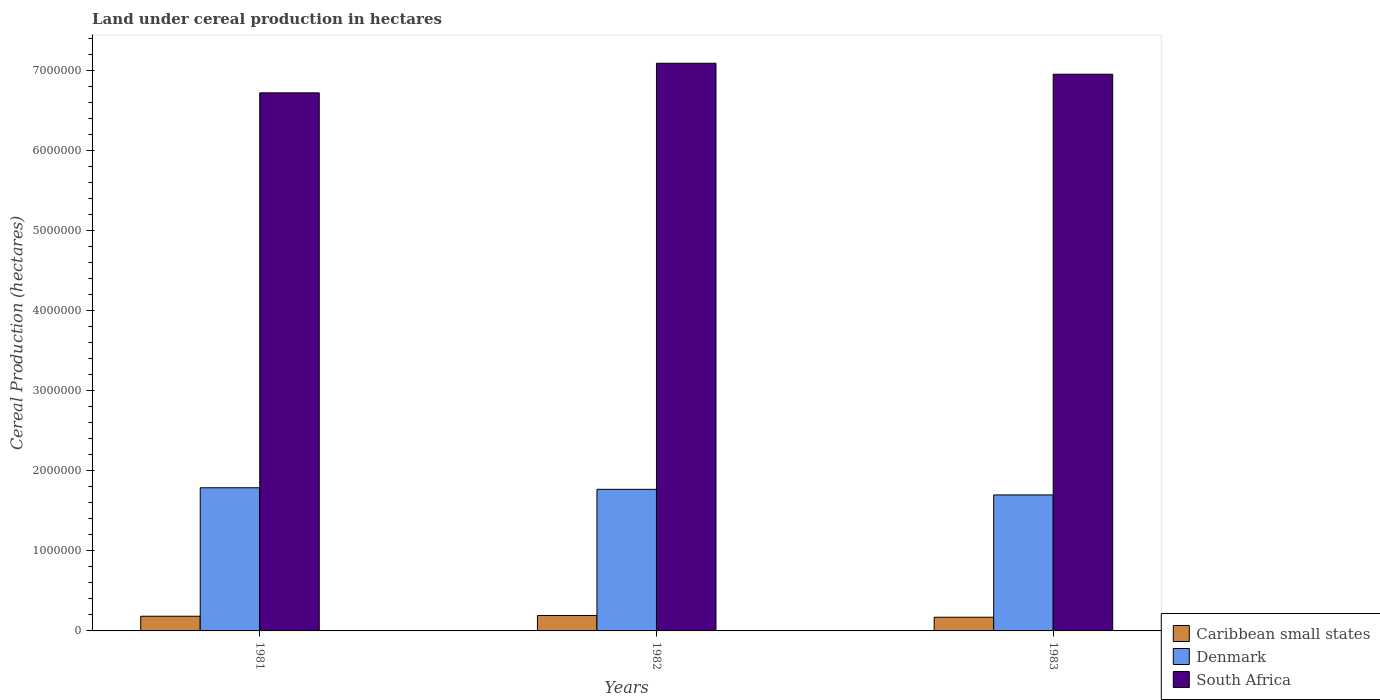How many different coloured bars are there?
Provide a short and direct response. 3. Are the number of bars per tick equal to the number of legend labels?
Your answer should be very brief. Yes. How many bars are there on the 2nd tick from the right?
Ensure brevity in your answer.  3. What is the label of the 1st group of bars from the left?
Your answer should be compact. 1981. In how many cases, is the number of bars for a given year not equal to the number of legend labels?
Ensure brevity in your answer.  0. What is the land under cereal production in Caribbean small states in 1982?
Ensure brevity in your answer.  1.92e+05. Across all years, what is the maximum land under cereal production in Caribbean small states?
Your response must be concise. 1.92e+05. Across all years, what is the minimum land under cereal production in South Africa?
Give a very brief answer. 6.72e+06. In which year was the land under cereal production in Denmark minimum?
Your response must be concise. 1983. What is the total land under cereal production in Denmark in the graph?
Keep it short and to the point. 5.25e+06. What is the difference between the land under cereal production in South Africa in 1981 and that in 1982?
Provide a short and direct response. -3.70e+05. What is the difference between the land under cereal production in Denmark in 1981 and the land under cereal production in Caribbean small states in 1982?
Your response must be concise. 1.60e+06. What is the average land under cereal production in Caribbean small states per year?
Offer a terse response. 1.82e+05. In the year 1981, what is the difference between the land under cereal production in Caribbean small states and land under cereal production in South Africa?
Ensure brevity in your answer.  -6.53e+06. What is the ratio of the land under cereal production in Denmark in 1982 to that in 1983?
Your answer should be very brief. 1.04. Is the difference between the land under cereal production in Caribbean small states in 1981 and 1982 greater than the difference between the land under cereal production in South Africa in 1981 and 1982?
Offer a terse response. Yes. What is the difference between the highest and the second highest land under cereal production in South Africa?
Give a very brief answer. 1.37e+05. What is the difference between the highest and the lowest land under cereal production in South Africa?
Give a very brief answer. 3.70e+05. In how many years, is the land under cereal production in Caribbean small states greater than the average land under cereal production in Caribbean small states taken over all years?
Provide a succinct answer. 2. What does the 3rd bar from the left in 1983 represents?
Provide a succinct answer. South Africa. What does the 1st bar from the right in 1982 represents?
Keep it short and to the point. South Africa. Is it the case that in every year, the sum of the land under cereal production in Denmark and land under cereal production in Caribbean small states is greater than the land under cereal production in South Africa?
Offer a terse response. No. Are the values on the major ticks of Y-axis written in scientific E-notation?
Offer a terse response. No. Does the graph contain grids?
Keep it short and to the point. No. How many legend labels are there?
Give a very brief answer. 3. What is the title of the graph?
Offer a very short reply. Land under cereal production in hectares. What is the label or title of the X-axis?
Offer a very short reply. Years. What is the label or title of the Y-axis?
Offer a terse response. Cereal Production (hectares). What is the Cereal Production (hectares) of Caribbean small states in 1981?
Provide a succinct answer. 1.83e+05. What is the Cereal Production (hectares) of Denmark in 1981?
Give a very brief answer. 1.79e+06. What is the Cereal Production (hectares) of South Africa in 1981?
Provide a succinct answer. 6.72e+06. What is the Cereal Production (hectares) of Caribbean small states in 1982?
Make the answer very short. 1.92e+05. What is the Cereal Production (hectares) of Denmark in 1982?
Your response must be concise. 1.77e+06. What is the Cereal Production (hectares) in South Africa in 1982?
Make the answer very short. 7.09e+06. What is the Cereal Production (hectares) in Caribbean small states in 1983?
Keep it short and to the point. 1.71e+05. What is the Cereal Production (hectares) of Denmark in 1983?
Make the answer very short. 1.70e+06. What is the Cereal Production (hectares) in South Africa in 1983?
Your answer should be compact. 6.95e+06. Across all years, what is the maximum Cereal Production (hectares) of Caribbean small states?
Offer a very short reply. 1.92e+05. Across all years, what is the maximum Cereal Production (hectares) of Denmark?
Provide a short and direct response. 1.79e+06. Across all years, what is the maximum Cereal Production (hectares) of South Africa?
Offer a very short reply. 7.09e+06. Across all years, what is the minimum Cereal Production (hectares) of Caribbean small states?
Provide a succinct answer. 1.71e+05. Across all years, what is the minimum Cereal Production (hectares) in Denmark?
Ensure brevity in your answer.  1.70e+06. Across all years, what is the minimum Cereal Production (hectares) in South Africa?
Your answer should be compact. 6.72e+06. What is the total Cereal Production (hectares) of Caribbean small states in the graph?
Give a very brief answer. 5.46e+05. What is the total Cereal Production (hectares) in Denmark in the graph?
Offer a terse response. 5.25e+06. What is the total Cereal Production (hectares) of South Africa in the graph?
Make the answer very short. 2.08e+07. What is the difference between the Cereal Production (hectares) of Caribbean small states in 1981 and that in 1982?
Provide a short and direct response. -8719. What is the difference between the Cereal Production (hectares) in Denmark in 1981 and that in 1982?
Give a very brief answer. 1.95e+04. What is the difference between the Cereal Production (hectares) of South Africa in 1981 and that in 1982?
Your answer should be compact. -3.70e+05. What is the difference between the Cereal Production (hectares) of Caribbean small states in 1981 and that in 1983?
Provide a short and direct response. 1.26e+04. What is the difference between the Cereal Production (hectares) in Denmark in 1981 and that in 1983?
Your answer should be very brief. 8.94e+04. What is the difference between the Cereal Production (hectares) of South Africa in 1981 and that in 1983?
Provide a succinct answer. -2.32e+05. What is the difference between the Cereal Production (hectares) in Caribbean small states in 1982 and that in 1983?
Make the answer very short. 2.13e+04. What is the difference between the Cereal Production (hectares) in Denmark in 1982 and that in 1983?
Your answer should be compact. 6.99e+04. What is the difference between the Cereal Production (hectares) of South Africa in 1982 and that in 1983?
Provide a short and direct response. 1.37e+05. What is the difference between the Cereal Production (hectares) in Caribbean small states in 1981 and the Cereal Production (hectares) in Denmark in 1982?
Your answer should be very brief. -1.58e+06. What is the difference between the Cereal Production (hectares) of Caribbean small states in 1981 and the Cereal Production (hectares) of South Africa in 1982?
Your answer should be compact. -6.90e+06. What is the difference between the Cereal Production (hectares) of Denmark in 1981 and the Cereal Production (hectares) of South Africa in 1982?
Provide a short and direct response. -5.30e+06. What is the difference between the Cereal Production (hectares) of Caribbean small states in 1981 and the Cereal Production (hectares) of Denmark in 1983?
Ensure brevity in your answer.  -1.51e+06. What is the difference between the Cereal Production (hectares) of Caribbean small states in 1981 and the Cereal Production (hectares) of South Africa in 1983?
Ensure brevity in your answer.  -6.77e+06. What is the difference between the Cereal Production (hectares) in Denmark in 1981 and the Cereal Production (hectares) in South Africa in 1983?
Your answer should be compact. -5.16e+06. What is the difference between the Cereal Production (hectares) in Caribbean small states in 1982 and the Cereal Production (hectares) in Denmark in 1983?
Your response must be concise. -1.51e+06. What is the difference between the Cereal Production (hectares) of Caribbean small states in 1982 and the Cereal Production (hectares) of South Africa in 1983?
Your response must be concise. -6.76e+06. What is the difference between the Cereal Production (hectares) in Denmark in 1982 and the Cereal Production (hectares) in South Africa in 1983?
Make the answer very short. -5.18e+06. What is the average Cereal Production (hectares) in Caribbean small states per year?
Provide a short and direct response. 1.82e+05. What is the average Cereal Production (hectares) of Denmark per year?
Make the answer very short. 1.75e+06. What is the average Cereal Production (hectares) of South Africa per year?
Your answer should be compact. 6.92e+06. In the year 1981, what is the difference between the Cereal Production (hectares) of Caribbean small states and Cereal Production (hectares) of Denmark?
Give a very brief answer. -1.60e+06. In the year 1981, what is the difference between the Cereal Production (hectares) in Caribbean small states and Cereal Production (hectares) in South Africa?
Provide a short and direct response. -6.53e+06. In the year 1981, what is the difference between the Cereal Production (hectares) of Denmark and Cereal Production (hectares) of South Africa?
Provide a short and direct response. -4.93e+06. In the year 1982, what is the difference between the Cereal Production (hectares) in Caribbean small states and Cereal Production (hectares) in Denmark?
Make the answer very short. -1.58e+06. In the year 1982, what is the difference between the Cereal Production (hectares) in Caribbean small states and Cereal Production (hectares) in South Africa?
Keep it short and to the point. -6.89e+06. In the year 1982, what is the difference between the Cereal Production (hectares) in Denmark and Cereal Production (hectares) in South Africa?
Your response must be concise. -5.32e+06. In the year 1983, what is the difference between the Cereal Production (hectares) of Caribbean small states and Cereal Production (hectares) of Denmark?
Offer a terse response. -1.53e+06. In the year 1983, what is the difference between the Cereal Production (hectares) of Caribbean small states and Cereal Production (hectares) of South Africa?
Offer a terse response. -6.78e+06. In the year 1983, what is the difference between the Cereal Production (hectares) in Denmark and Cereal Production (hectares) in South Africa?
Ensure brevity in your answer.  -5.25e+06. What is the ratio of the Cereal Production (hectares) in Caribbean small states in 1981 to that in 1982?
Offer a terse response. 0.95. What is the ratio of the Cereal Production (hectares) of Denmark in 1981 to that in 1982?
Offer a terse response. 1.01. What is the ratio of the Cereal Production (hectares) in South Africa in 1981 to that in 1982?
Ensure brevity in your answer.  0.95. What is the ratio of the Cereal Production (hectares) of Caribbean small states in 1981 to that in 1983?
Make the answer very short. 1.07. What is the ratio of the Cereal Production (hectares) of Denmark in 1981 to that in 1983?
Offer a terse response. 1.05. What is the ratio of the Cereal Production (hectares) of South Africa in 1981 to that in 1983?
Your answer should be very brief. 0.97. What is the ratio of the Cereal Production (hectares) of Denmark in 1982 to that in 1983?
Make the answer very short. 1.04. What is the ratio of the Cereal Production (hectares) of South Africa in 1982 to that in 1983?
Ensure brevity in your answer.  1.02. What is the difference between the highest and the second highest Cereal Production (hectares) in Caribbean small states?
Your answer should be compact. 8719. What is the difference between the highest and the second highest Cereal Production (hectares) in Denmark?
Provide a short and direct response. 1.95e+04. What is the difference between the highest and the second highest Cereal Production (hectares) of South Africa?
Keep it short and to the point. 1.37e+05. What is the difference between the highest and the lowest Cereal Production (hectares) of Caribbean small states?
Your answer should be very brief. 2.13e+04. What is the difference between the highest and the lowest Cereal Production (hectares) of Denmark?
Offer a very short reply. 8.94e+04. What is the difference between the highest and the lowest Cereal Production (hectares) of South Africa?
Make the answer very short. 3.70e+05. 